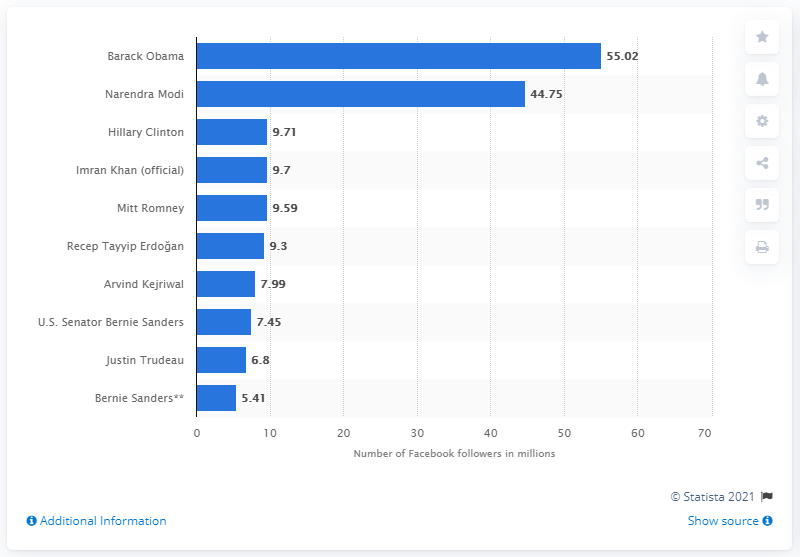Outline some significant characteristics in this image. Barack Obama, the former President of the United States, was ranked first on Facebook in June 2020. 